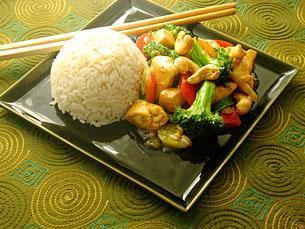How many dinosaurs are in the picture?
Give a very brief answer. 0. How many people are eating the food?
Give a very brief answer. 0. 